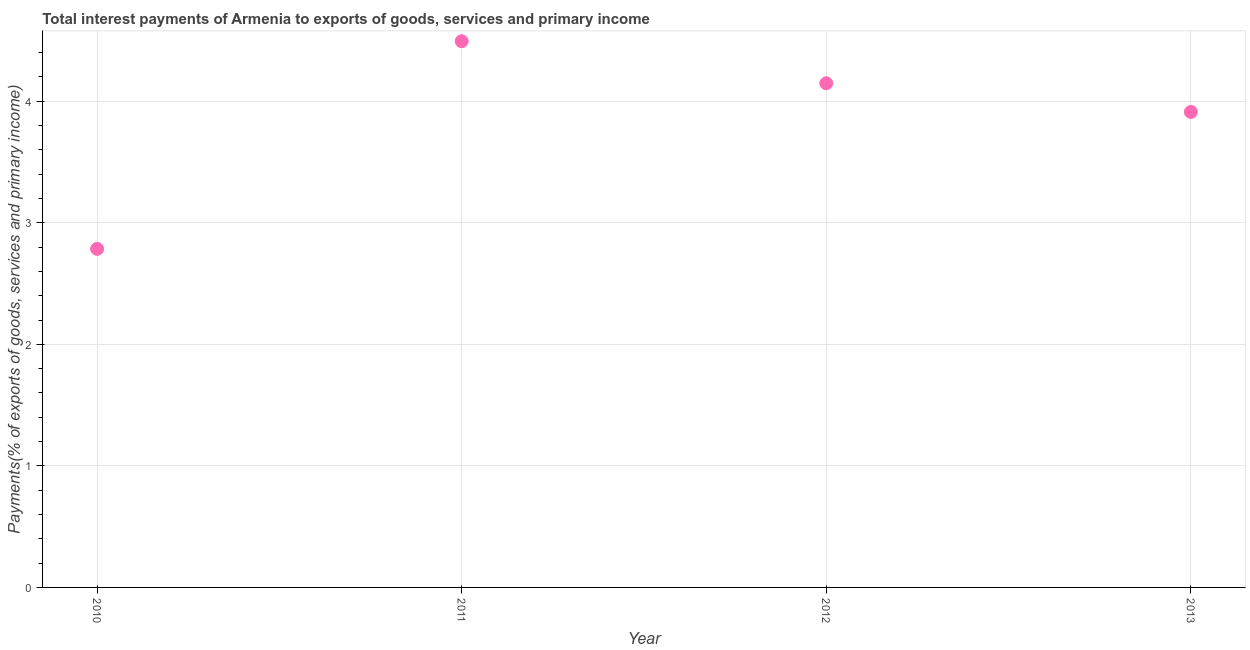What is the total interest payments on external debt in 2013?
Provide a short and direct response. 3.91. Across all years, what is the maximum total interest payments on external debt?
Keep it short and to the point. 4.49. Across all years, what is the minimum total interest payments on external debt?
Your response must be concise. 2.79. What is the sum of the total interest payments on external debt?
Ensure brevity in your answer.  15.34. What is the difference between the total interest payments on external debt in 2011 and 2012?
Your response must be concise. 0.35. What is the average total interest payments on external debt per year?
Ensure brevity in your answer.  3.84. What is the median total interest payments on external debt?
Provide a short and direct response. 4.03. What is the ratio of the total interest payments on external debt in 2010 to that in 2013?
Your response must be concise. 0.71. What is the difference between the highest and the second highest total interest payments on external debt?
Your response must be concise. 0.35. What is the difference between the highest and the lowest total interest payments on external debt?
Your answer should be very brief. 1.71. In how many years, is the total interest payments on external debt greater than the average total interest payments on external debt taken over all years?
Your response must be concise. 3. Does the total interest payments on external debt monotonically increase over the years?
Ensure brevity in your answer.  No. How many years are there in the graph?
Provide a succinct answer. 4. What is the difference between two consecutive major ticks on the Y-axis?
Offer a terse response. 1. Are the values on the major ticks of Y-axis written in scientific E-notation?
Your response must be concise. No. What is the title of the graph?
Offer a very short reply. Total interest payments of Armenia to exports of goods, services and primary income. What is the label or title of the Y-axis?
Offer a terse response. Payments(% of exports of goods, services and primary income). What is the Payments(% of exports of goods, services and primary income) in 2010?
Offer a very short reply. 2.79. What is the Payments(% of exports of goods, services and primary income) in 2011?
Give a very brief answer. 4.49. What is the Payments(% of exports of goods, services and primary income) in 2012?
Make the answer very short. 4.15. What is the Payments(% of exports of goods, services and primary income) in 2013?
Offer a terse response. 3.91. What is the difference between the Payments(% of exports of goods, services and primary income) in 2010 and 2011?
Your answer should be very brief. -1.71. What is the difference between the Payments(% of exports of goods, services and primary income) in 2010 and 2012?
Give a very brief answer. -1.36. What is the difference between the Payments(% of exports of goods, services and primary income) in 2010 and 2013?
Your answer should be compact. -1.13. What is the difference between the Payments(% of exports of goods, services and primary income) in 2011 and 2012?
Make the answer very short. 0.35. What is the difference between the Payments(% of exports of goods, services and primary income) in 2011 and 2013?
Give a very brief answer. 0.58. What is the difference between the Payments(% of exports of goods, services and primary income) in 2012 and 2013?
Provide a succinct answer. 0.24. What is the ratio of the Payments(% of exports of goods, services and primary income) in 2010 to that in 2011?
Offer a terse response. 0.62. What is the ratio of the Payments(% of exports of goods, services and primary income) in 2010 to that in 2012?
Provide a short and direct response. 0.67. What is the ratio of the Payments(% of exports of goods, services and primary income) in 2010 to that in 2013?
Your answer should be very brief. 0.71. What is the ratio of the Payments(% of exports of goods, services and primary income) in 2011 to that in 2012?
Your answer should be very brief. 1.08. What is the ratio of the Payments(% of exports of goods, services and primary income) in 2011 to that in 2013?
Keep it short and to the point. 1.15. What is the ratio of the Payments(% of exports of goods, services and primary income) in 2012 to that in 2013?
Offer a very short reply. 1.06. 